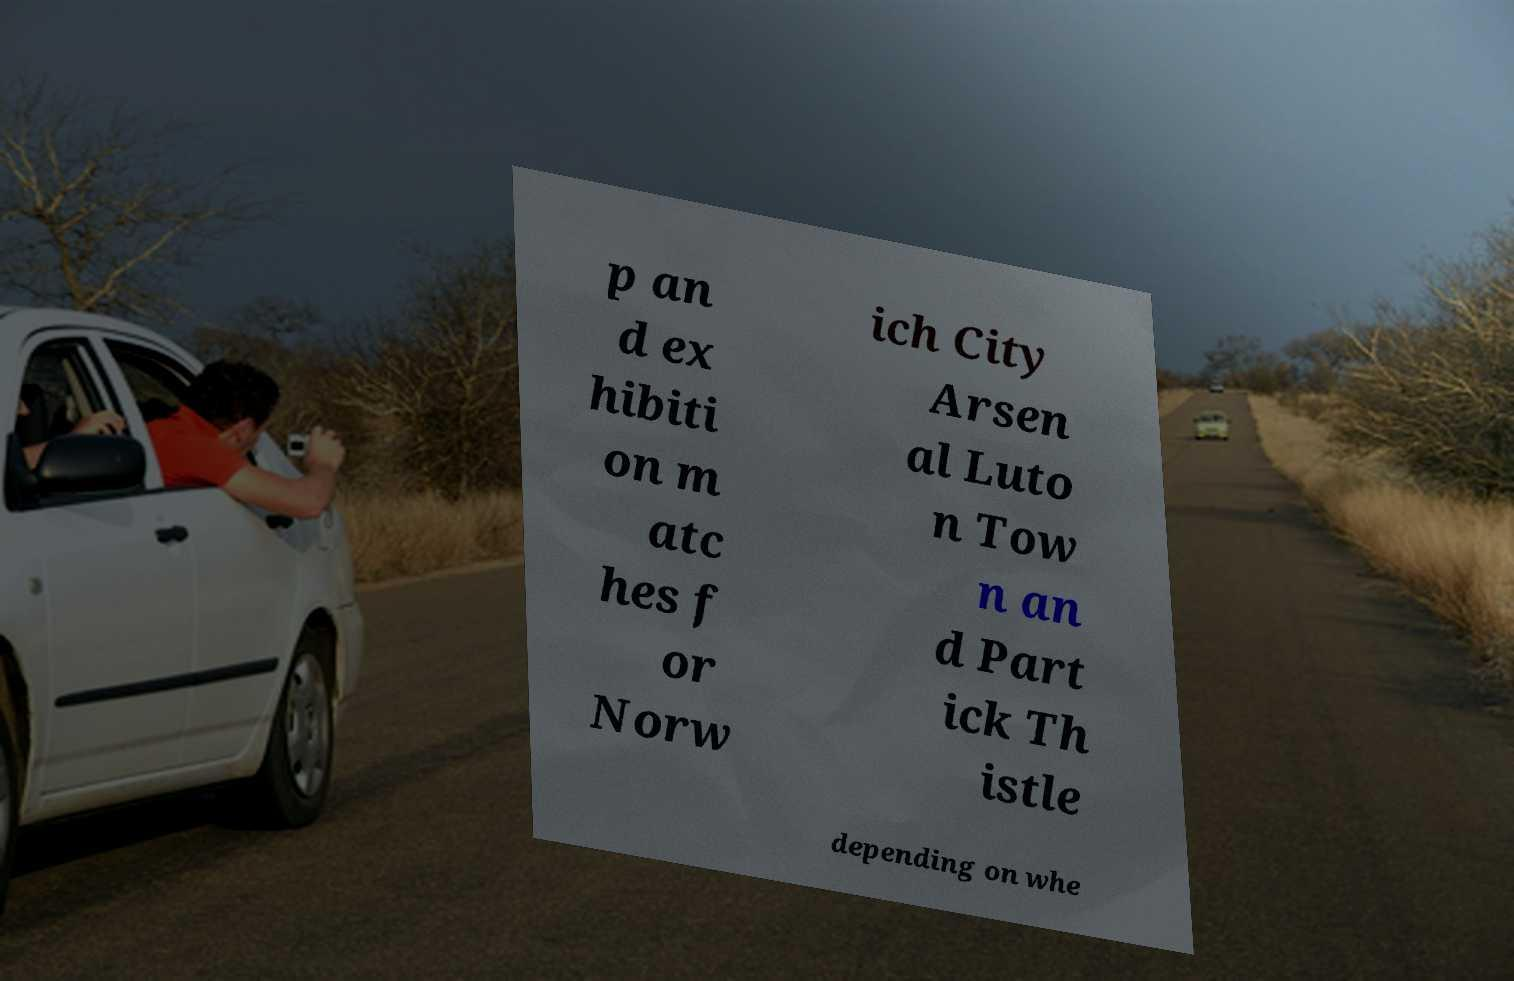Please identify and transcribe the text found in this image. p an d ex hibiti on m atc hes f or Norw ich City Arsen al Luto n Tow n an d Part ick Th istle depending on whe 